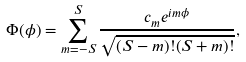Convert formula to latex. <formula><loc_0><loc_0><loc_500><loc_500>\Phi ( \phi ) = \sum _ { m = - S } ^ { S } \frac { c _ { m } e ^ { i m \phi } } { \sqrt { ( S - m ) ! ( S + m ) ! } } ,</formula> 